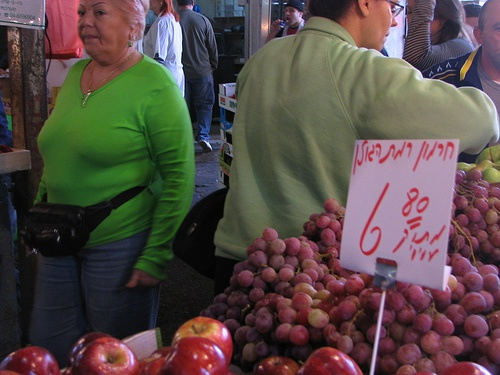Describe the objects in this image and their specific colors. I can see people in gray, black, darkgreen, and green tones, people in gray, darkgreen, and black tones, people in gray, black, and purple tones, people in gray, black, navy, and darkblue tones, and people in gray, purple, navy, and black tones in this image. 